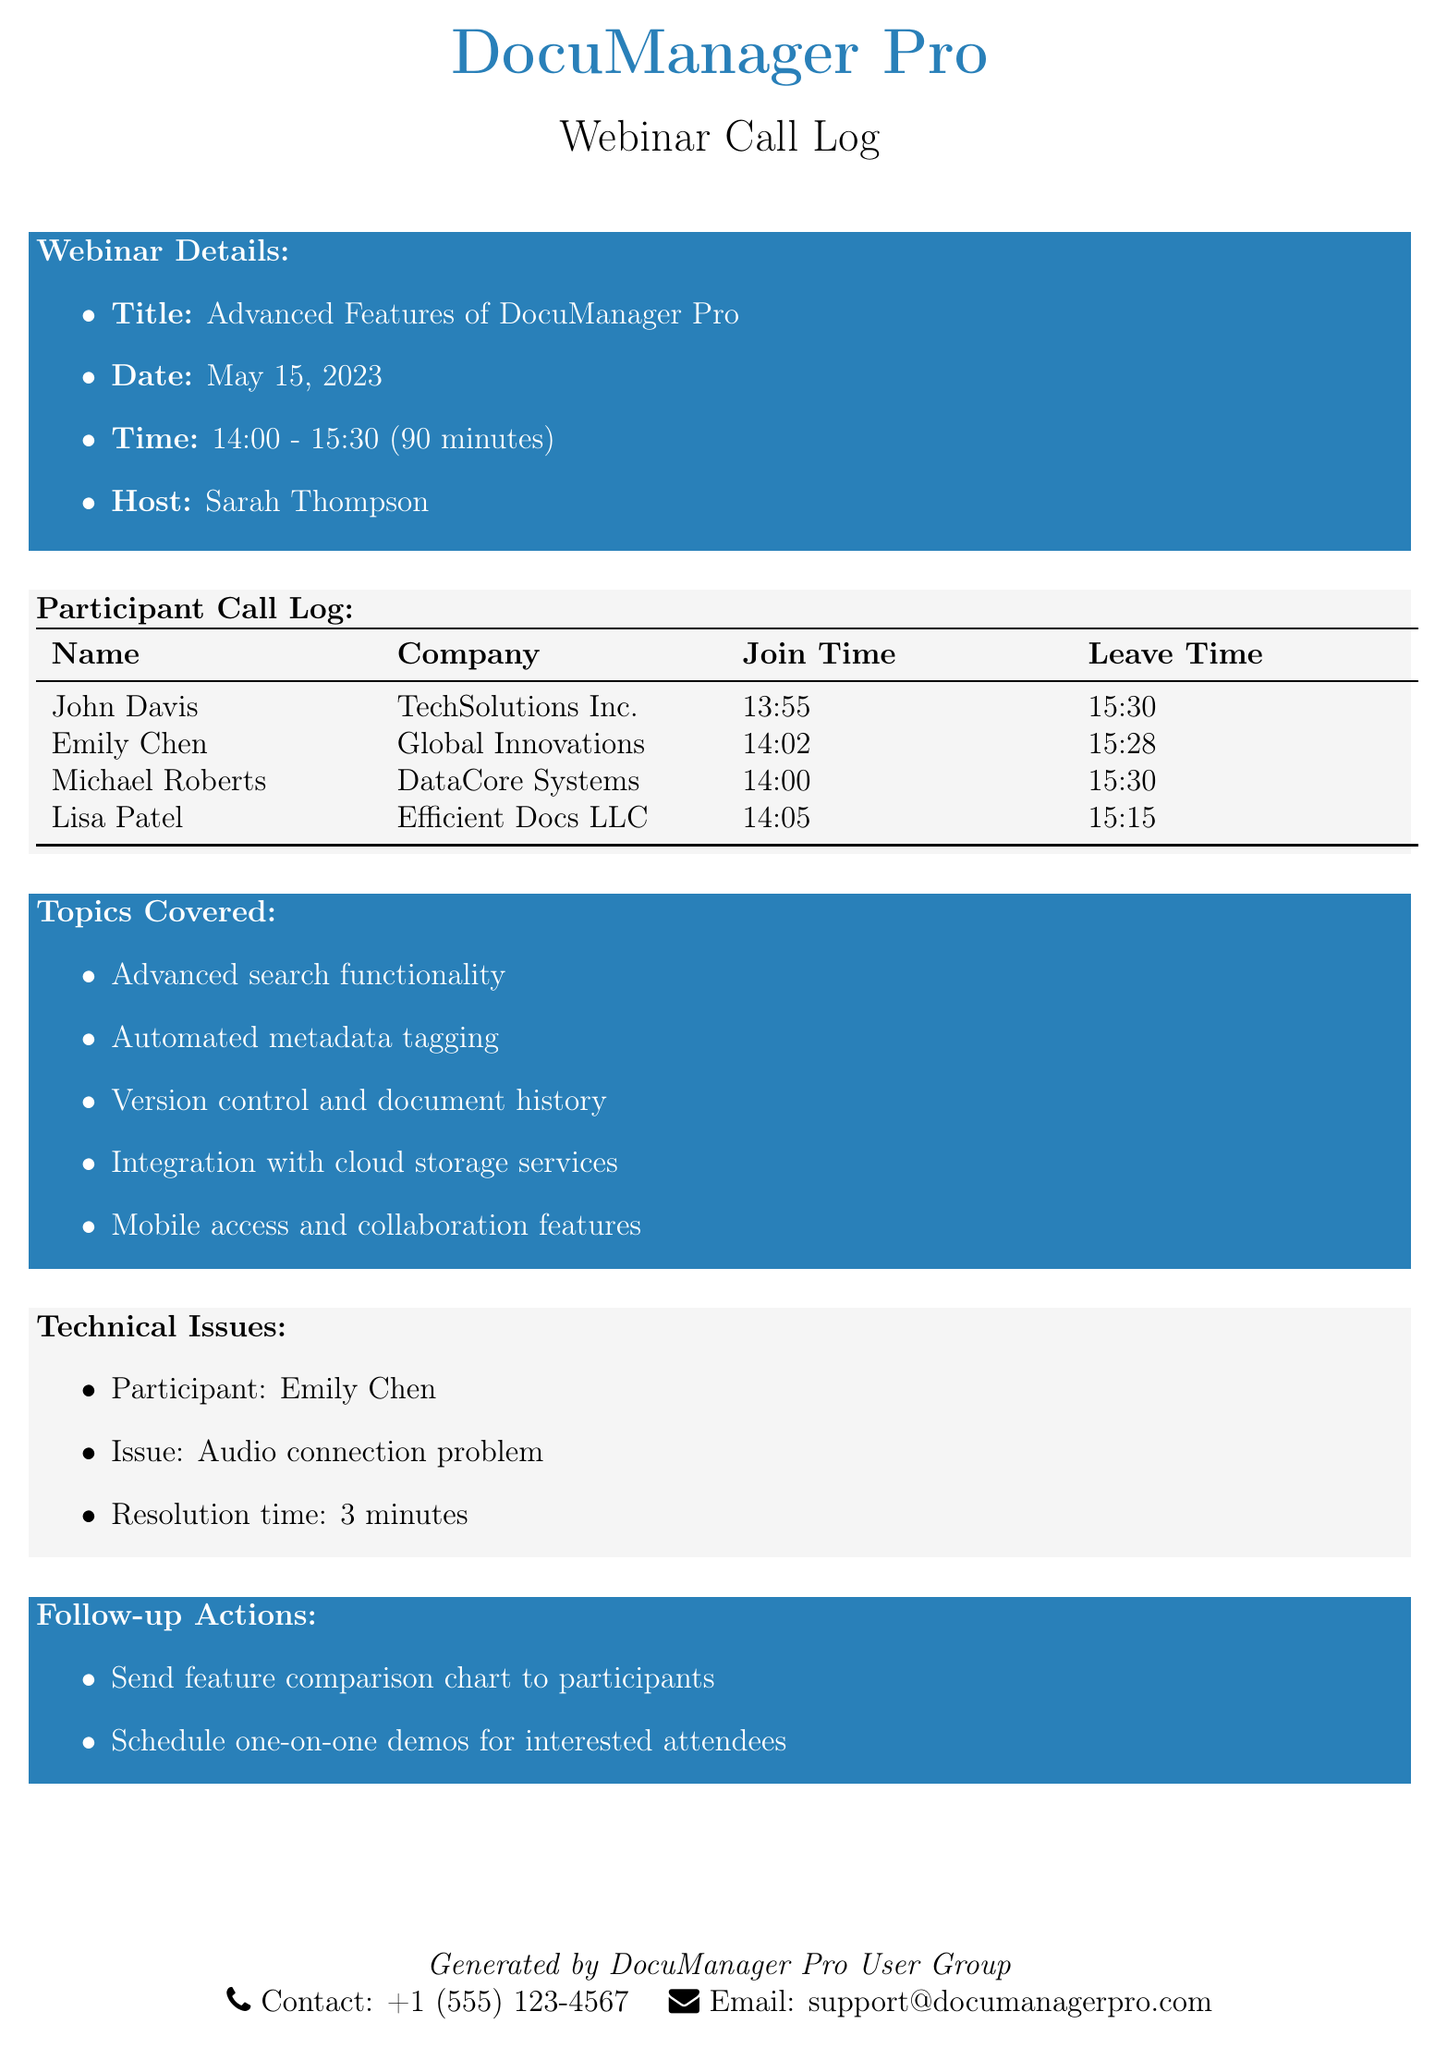What is the title of the webinar? The title of the webinar is stated in the document as "Advanced Features of DocuManager Pro."
Answer: Advanced Features of DocuManager Pro Who hosted the webinar? The host of the webinar is mentioned in the document.
Answer: Sarah Thompson What is the duration of the webinar in minutes? The duration of the webinar is provided as 90 minutes in the document.
Answer: 90 minutes What was the technical issue faced by Emily Chen? The specific issue faced by Emily Chen is listed in the document.
Answer: Audio connection problem Which company did Michael Roberts represent? The company of Michael Roberts is noted in the participant log.
Answer: DataCore Systems At what time did Lisa Patel join the webinar? The join time for Lisa Patel is clearly outlined in the document.
Answer: 14:05 How many participants were logged into the webinar by 14:00? Participants who joined at or before 14:00 are counted from the provided log.
Answer: 2 What was one of the follow-up actions after the webinar? A follow-up action planned after the webinar is listed in the document.
Answer: Send feature comparison chart to participants How long did it take to resolve Emily Chen's issue? The resolution time for Emily Chen's technical issue is specified in the document.
Answer: 3 minutes 